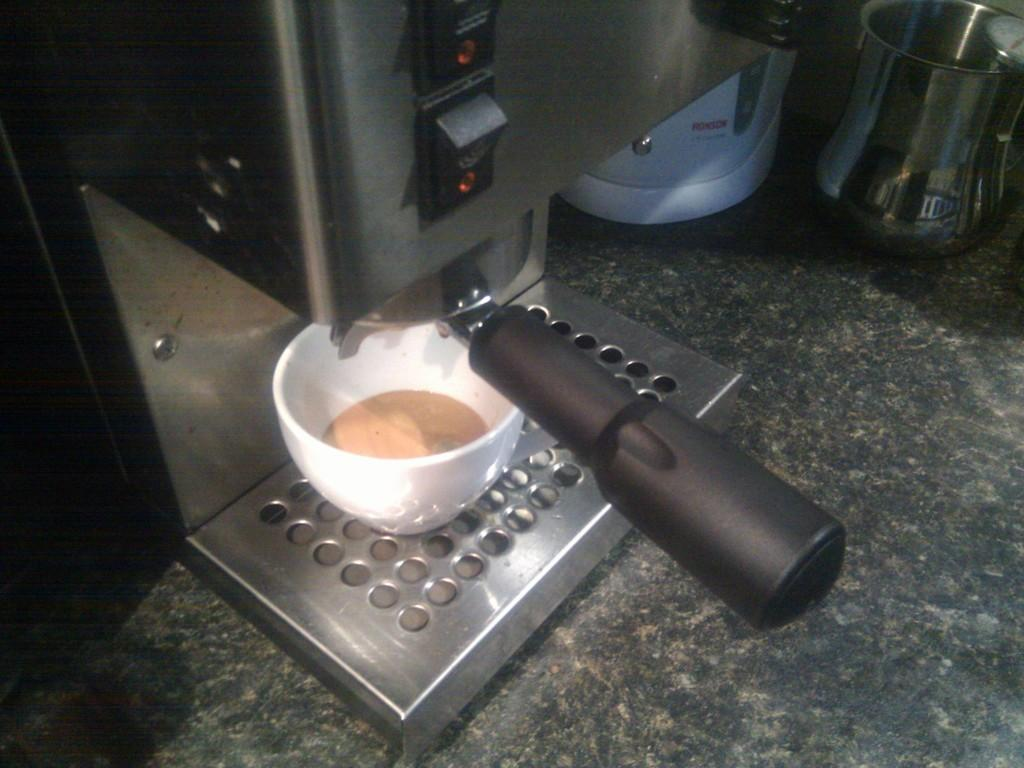What type of appliance is visible in the image? There is a coffee machine in the image. What is used for holding liquids in the image? There is a cup and a steel glass in the image. Can you describe another object on the surface in the image? There is another object on the surface in the image, but its specific details are not mentioned in the facts provided. What type of silk material is draped over the coffee machine in the image? There is no silk material present in the image; the coffee machine and other objects are the only visible items. 